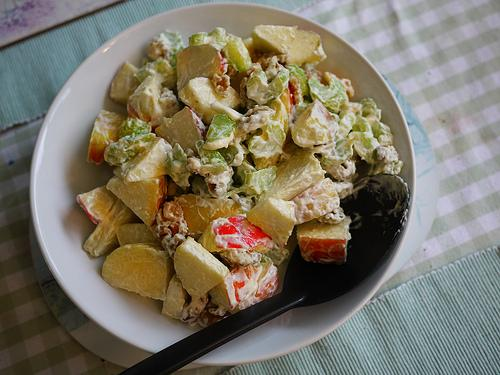Express the contents of the image artistically. A symphony of vibrant colors comes to life as assorted vegetables, dressing, and dishes perform a visually captivating dance upon the checkered green and white stage. Give a brief description of the food in the picture. There is an apple salad with roasted pecans, pieces of celery, and chunks of potatoes, all covered in dressing. Explain the image in a simple language to a child. There's a white dish with yummy veggies and apples mixed together, and there's a big black spoon for scooping. The table has a green and white squared cover. Imagine you are a tour guide commenting on the food in the image. How would you describe it? Ladies and gentlemen, we have here a lovely dish featuring a fresh and colorful apple salad with an assortment of garden vegetables drizzled in a tangy dressing and served with a large black spoon. Mention the main colors and objects in the scene. The scene contains a white bowl, black spoon, green and white checkered tablecloth, and assorted multicolored vegetables. Explain the image as if giving a report to a culinary magazine. In the impeccably set dining scene, we have a white bowl displaying a visually appetizing and diverse mix of vegetables tossed with pieces of apple and a creamy dressing. The serving ware consists of an elegant black serving spoon alongside a white round plate, all set upon a tastefully designed checkered green and white tablecloth. Describe the image with a focus on the table setting. The table is dressed with a green and white checkered tablecloth, a large white bowl filled with apple salad, and a black spoon resting on a white round plate. Describe the image as if telling a friend over the phone. There's this picture with a bowl of apple salad, veggies, and dressing, and beside it, there's a black serving spoon on the plate. The tablecloth is green, white, and checkered. Write a simple sentence describing what you see in the image. On a checkered green and white tablecloth lies a white bowl containing an assortment of vegetables, apples, and dressing, accompanied by a large black spoon. What are the primary objects the image contains? A white bowl with assorted vegetables, a black spoon, an apple piece, and a green and white checkered tablecloth. 